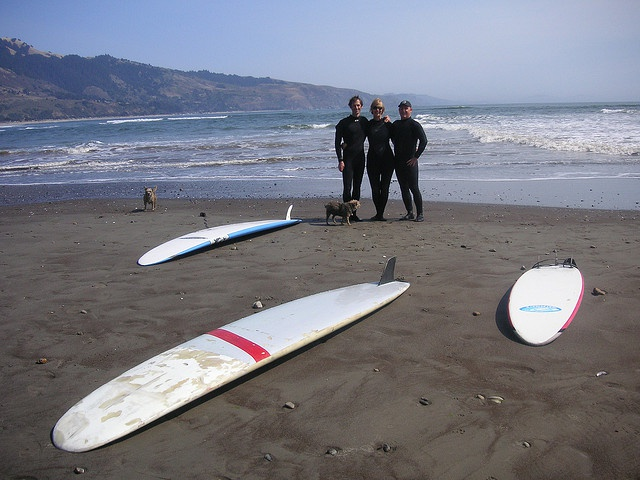Describe the objects in this image and their specific colors. I can see surfboard in gray, lightgray, beige, and darkgray tones, surfboard in gray, white, darkgray, and lightblue tones, people in gray, black, and darkgray tones, people in gray and black tones, and people in gray, black, and darkgray tones in this image. 